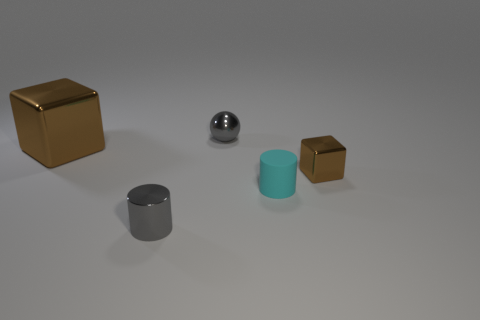Add 2 small green metal cubes. How many objects exist? 7 Subtract all cylinders. How many objects are left? 3 Subtract 0 yellow spheres. How many objects are left? 5 Subtract all big green shiny spheres. Subtract all small cyan objects. How many objects are left? 4 Add 2 tiny cyan things. How many tiny cyan things are left? 3 Add 3 big shiny blocks. How many big shiny blocks exist? 4 